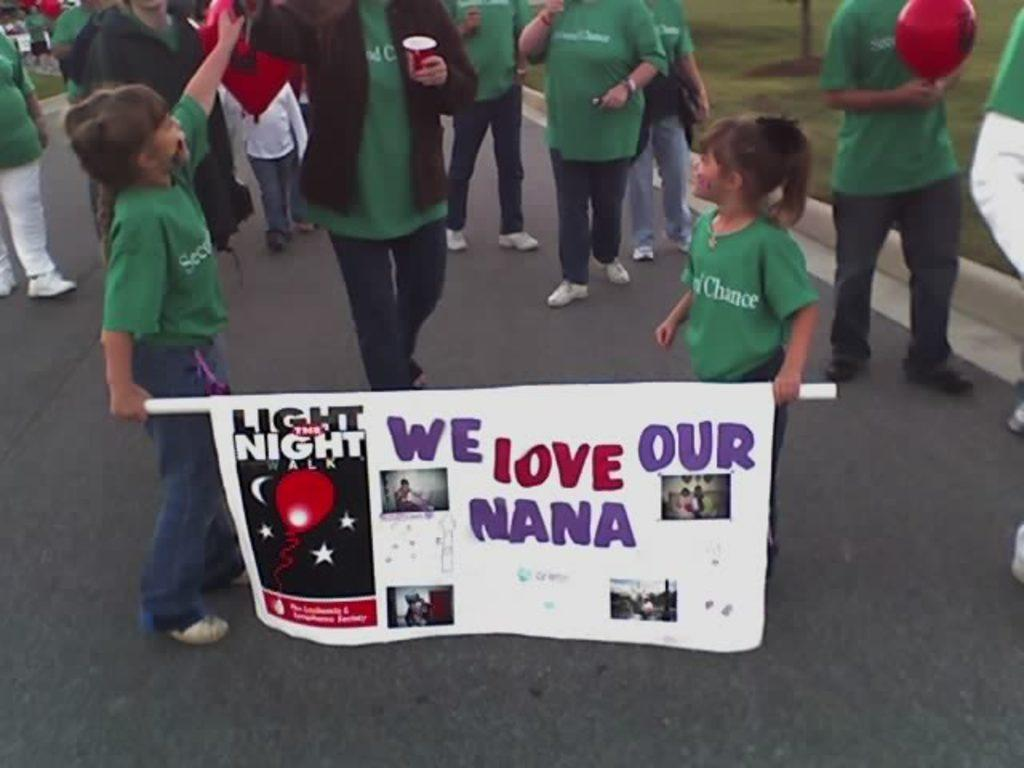What are the people in the image doing? The people in the image are standing on the road. Can you describe any specific actions or objects being held by the people? Some girls are holding a banner in the image. Are there any notable clothing items or colors being worn by the people? Some people are wearing green color t-shirts in the image. What degree does the father of the girl holding the banner have in the image? There is no information about a father or any degrees in the image. 